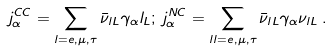Convert formula to latex. <formula><loc_0><loc_0><loc_500><loc_500>j ^ { C C } _ { \alpha } = \sum _ { l = e , \mu , \tau } \bar { \nu } _ { l L } \gamma _ { \alpha } l _ { L } ; \, j ^ { N C } _ { \alpha } = \sum _ { l l = e , \mu , \tau } \bar { \nu } _ { l L } \gamma _ { \alpha } \nu _ { l L } \, .</formula> 